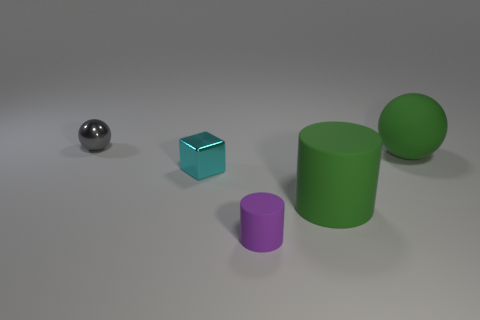Add 4 tiny metal spheres. How many objects exist? 9 Subtract all blocks. How many objects are left? 4 Subtract all big cyan metal blocks. Subtract all purple things. How many objects are left? 4 Add 1 gray metallic things. How many gray metallic things are left? 2 Add 4 tiny purple matte things. How many tiny purple matte things exist? 5 Subtract 1 green spheres. How many objects are left? 4 